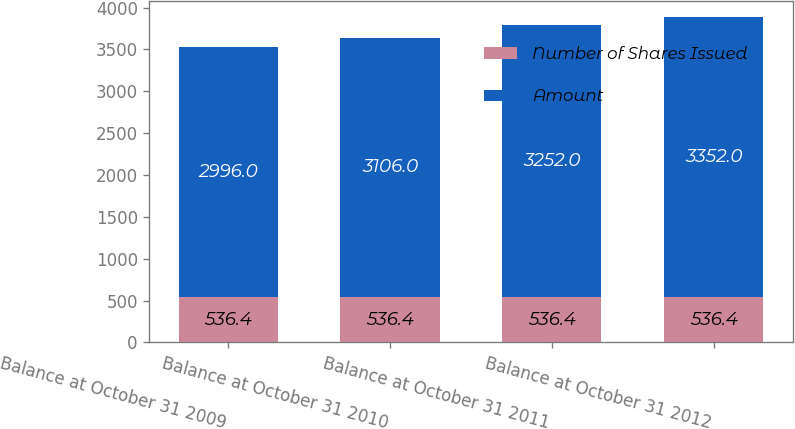Convert chart to OTSL. <chart><loc_0><loc_0><loc_500><loc_500><stacked_bar_chart><ecel><fcel>Balance at October 31 2009<fcel>Balance at October 31 2010<fcel>Balance at October 31 2011<fcel>Balance at October 31 2012<nl><fcel>Number of Shares Issued<fcel>536.4<fcel>536.4<fcel>536.4<fcel>536.4<nl><fcel>Amount<fcel>2996<fcel>3106<fcel>3252<fcel>3352<nl></chart> 